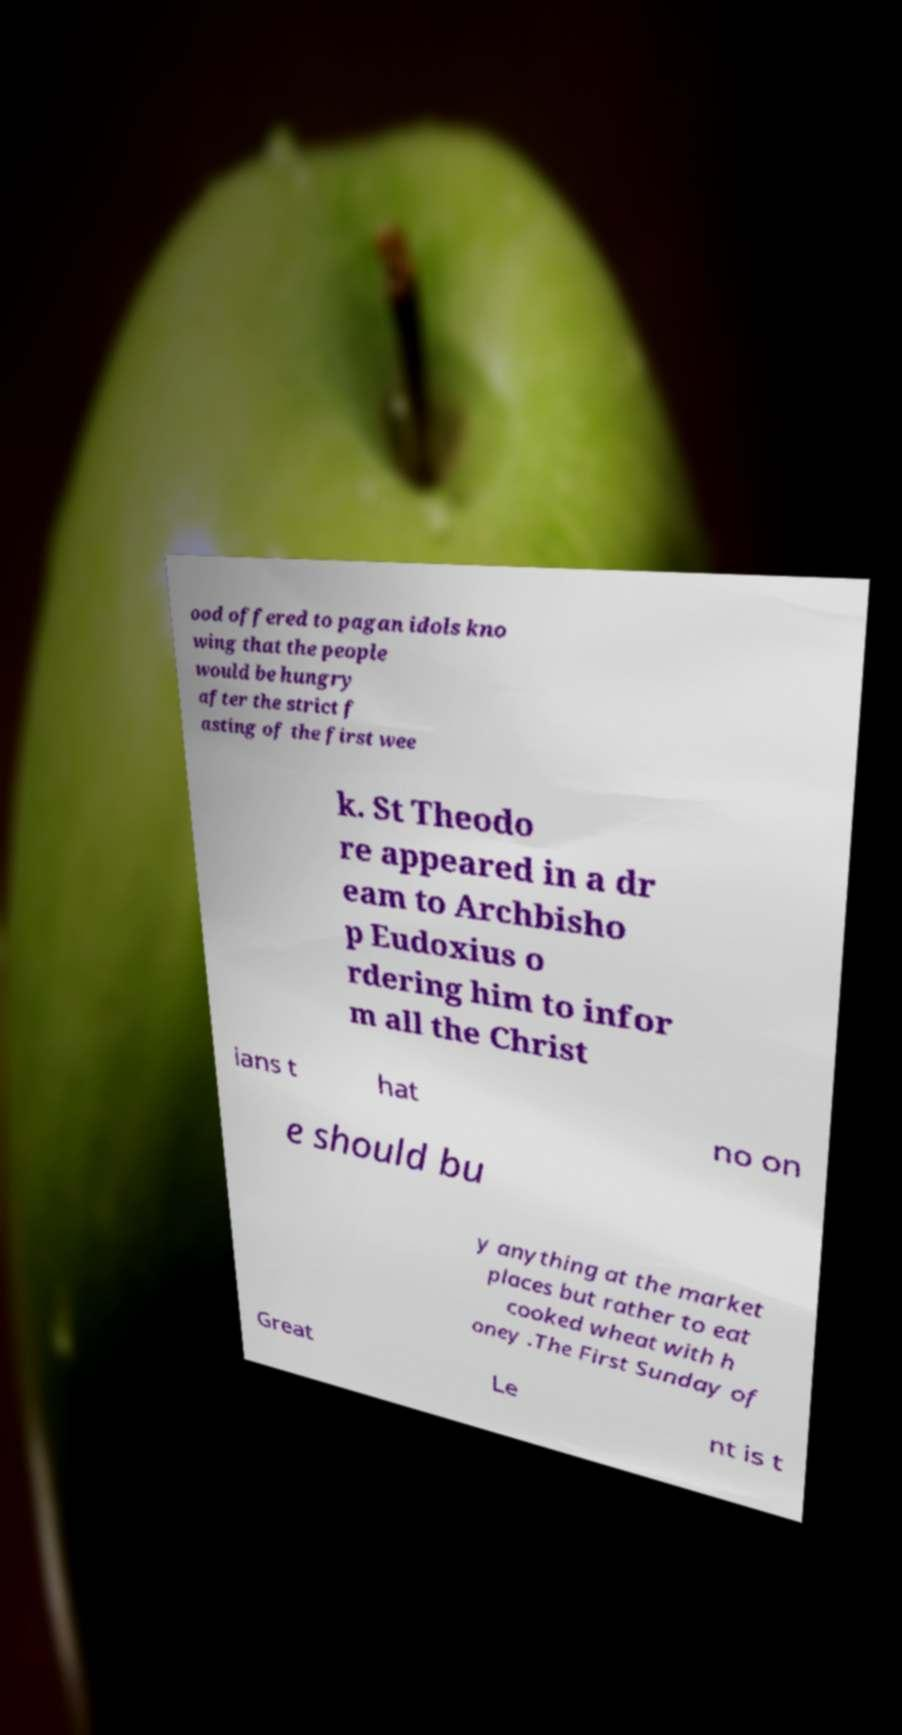Please read and relay the text visible in this image. What does it say? ood offered to pagan idols kno wing that the people would be hungry after the strict f asting of the first wee k. St Theodo re appeared in a dr eam to Archbisho p Eudoxius o rdering him to infor m all the Christ ians t hat no on e should bu y anything at the market places but rather to eat cooked wheat with h oney .The First Sunday of Great Le nt is t 